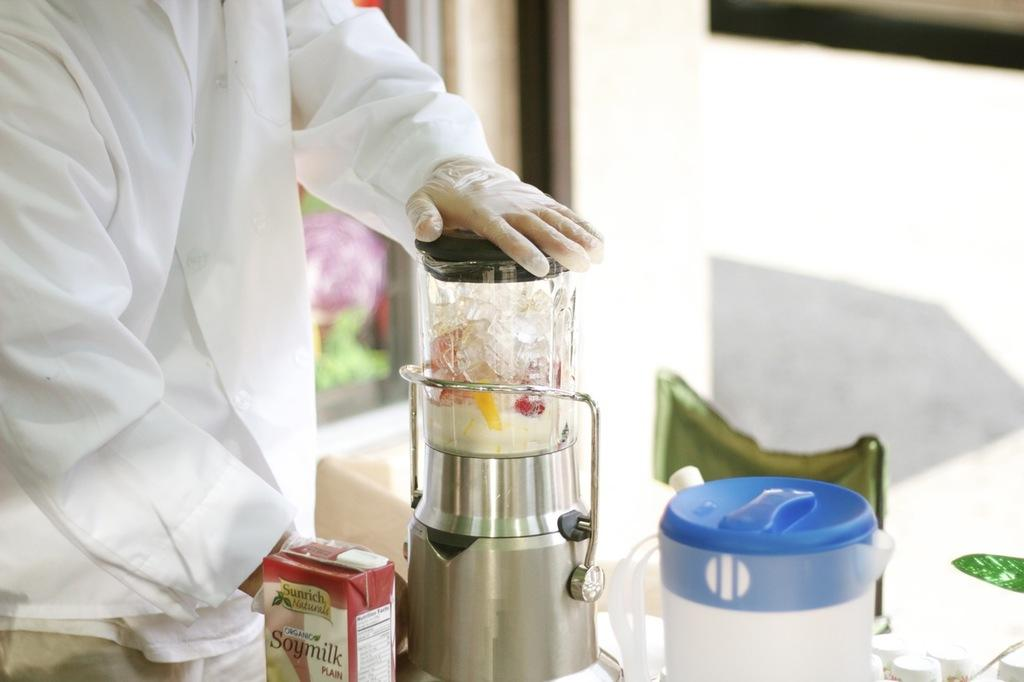<image>
Offer a succinct explanation of the picture presented. a box with the word soymilk on the front 